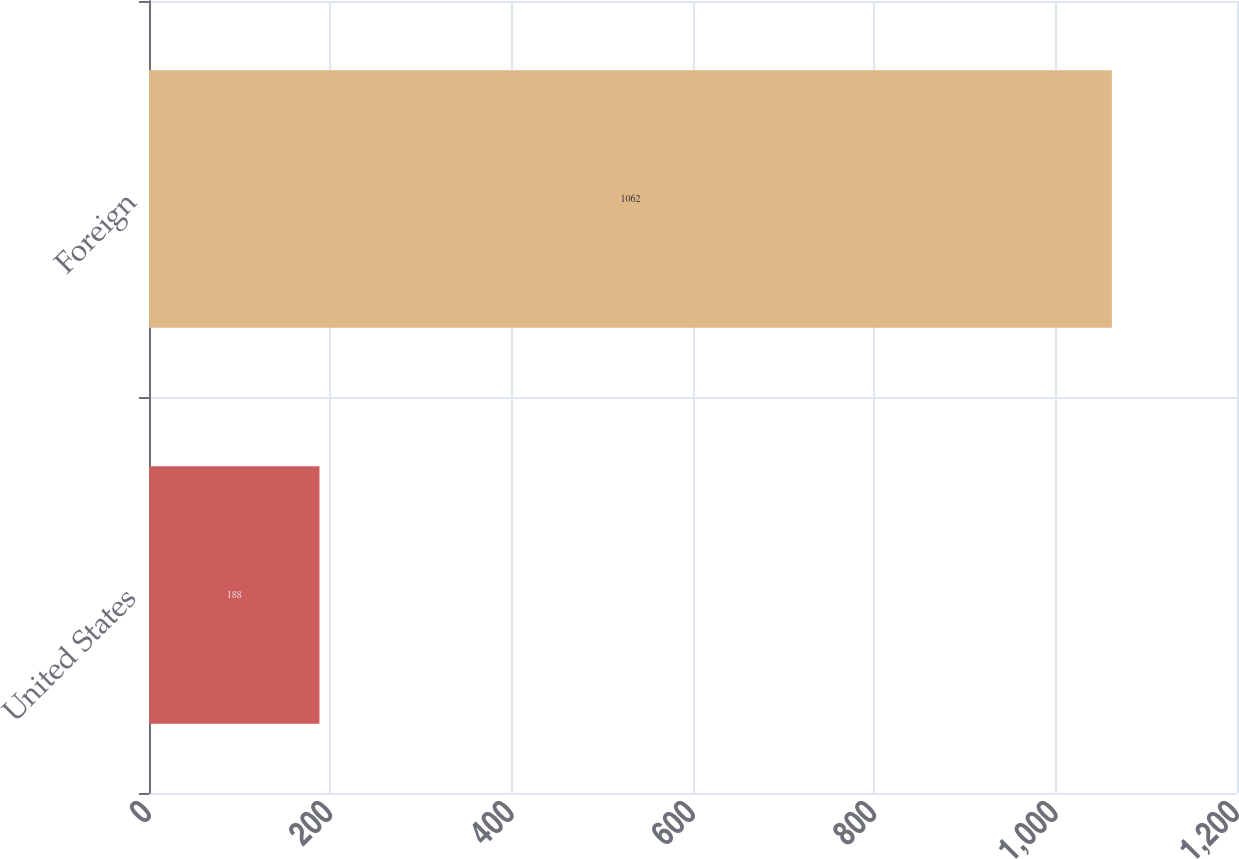Convert chart to OTSL. <chart><loc_0><loc_0><loc_500><loc_500><bar_chart><fcel>United States<fcel>Foreign<nl><fcel>188<fcel>1062<nl></chart> 